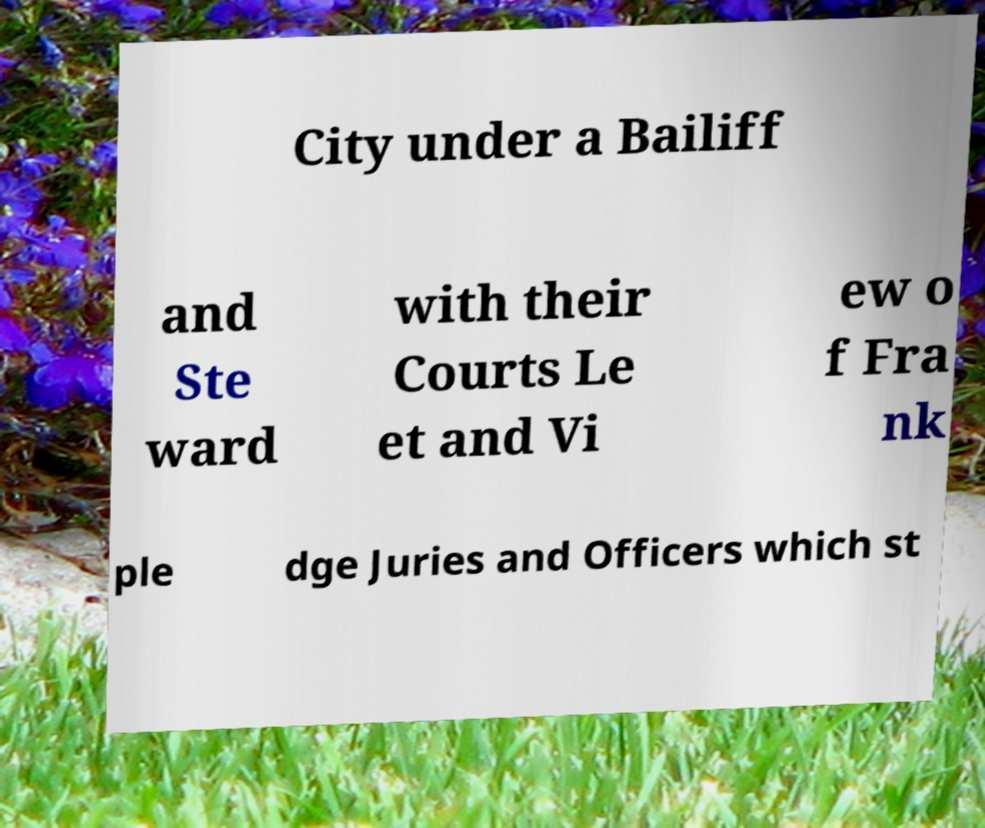Please read and relay the text visible in this image. What does it say? City under a Bailiff and Ste ward with their Courts Le et and Vi ew o f Fra nk ple dge Juries and Officers which st 